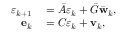<formula> <loc_0><loc_0><loc_500><loc_500>\begin{array} { r l } { \varepsilon _ { k + 1 } } & = \bar { A } \varepsilon _ { k } + \bar { G } \bar { w } _ { k } , } \\ { e _ { k } } & = C \varepsilon _ { k } + v _ { k } , } \end{array}</formula> 